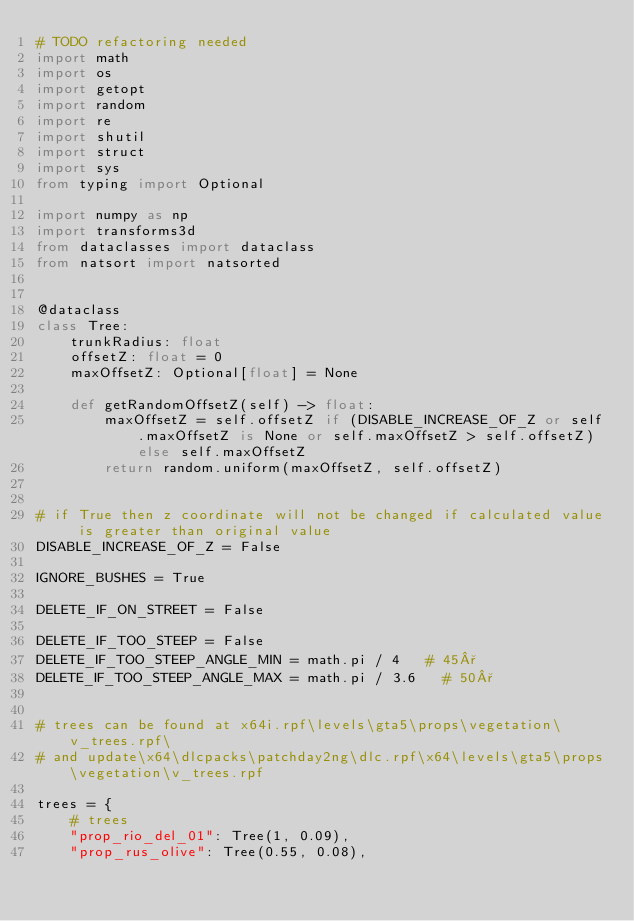<code> <loc_0><loc_0><loc_500><loc_500><_Python_># TODO refactoring needed
import math
import os
import getopt
import random
import re
import shutil
import struct
import sys
from typing import Optional

import numpy as np
import transforms3d
from dataclasses import dataclass
from natsort import natsorted


@dataclass
class Tree:
    trunkRadius: float
    offsetZ: float = 0
    maxOffsetZ: Optional[float] = None

    def getRandomOffsetZ(self) -> float:
        maxOffsetZ = self.offsetZ if (DISABLE_INCREASE_OF_Z or self.maxOffsetZ is None or self.maxOffsetZ > self.offsetZ) else self.maxOffsetZ
        return random.uniform(maxOffsetZ, self.offsetZ)


# if True then z coordinate will not be changed if calculated value is greater than original value
DISABLE_INCREASE_OF_Z = False

IGNORE_BUSHES = True

DELETE_IF_ON_STREET = False

DELETE_IF_TOO_STEEP = False
DELETE_IF_TOO_STEEP_ANGLE_MIN = math.pi / 4   # 45°
DELETE_IF_TOO_STEEP_ANGLE_MAX = math.pi / 3.6   # 50°


# trees can be found at x64i.rpf\levels\gta5\props\vegetation\v_trees.rpf\
# and update\x64\dlcpacks\patchday2ng\dlc.rpf\x64\levels\gta5\props\vegetation\v_trees.rpf

trees = {
    # trees
    "prop_rio_del_01": Tree(1, 0.09),
    "prop_rus_olive": Tree(0.55, 0.08),</code> 